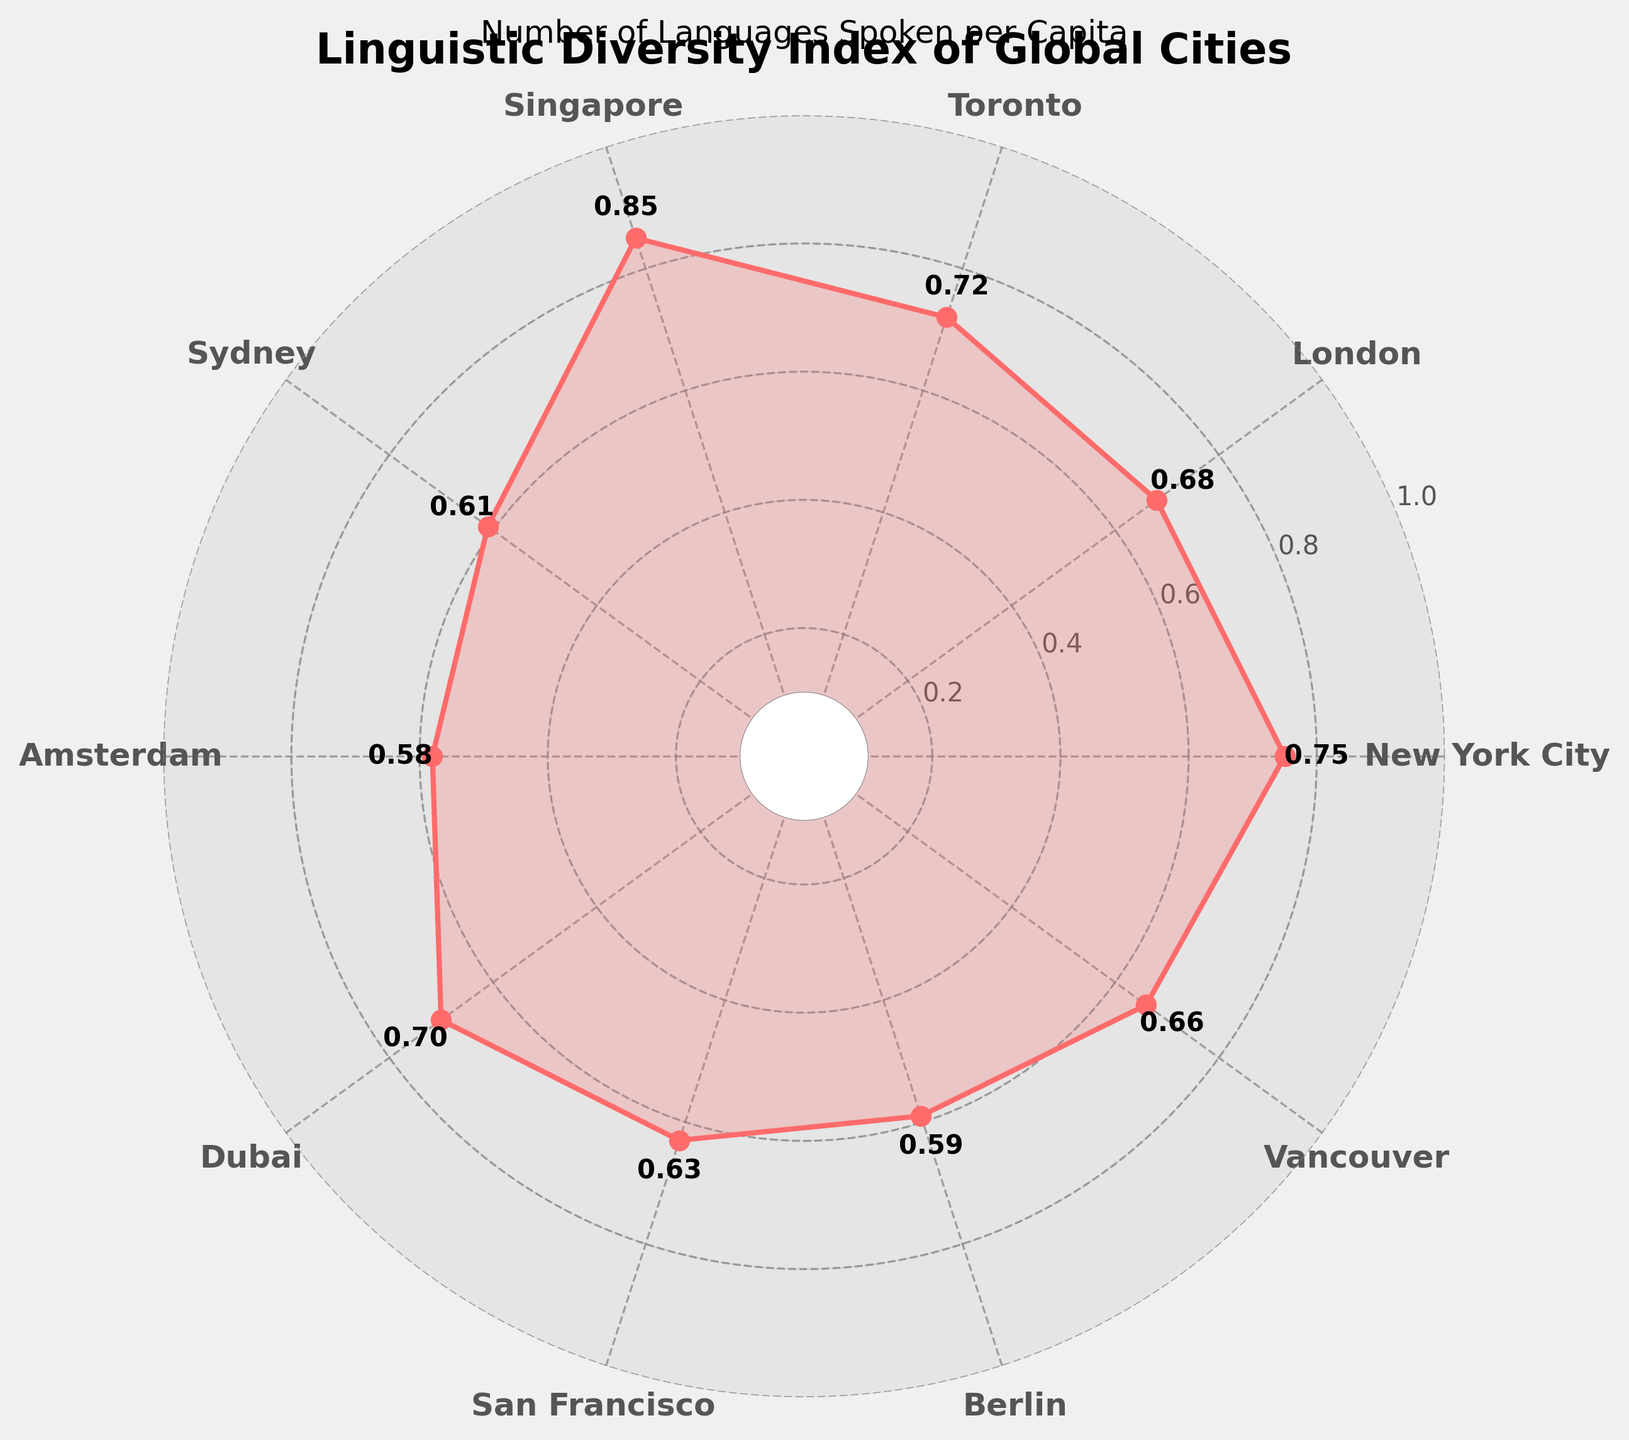What is the highest Linguistic Diversity Index value among the cities? Identify the point with the highest value on the gauge chart, which represents the highest Linguistic Diversity Index.
Answer: 0.85 (Singapore) Which city has the lowest Linguistic Diversity Index? Look for the point with the lowest value on the gauge chart and identify the corresponding city.
Answer: Amsterdam What is the Linguistic Diversity Index of New York City? Locate New York City on the gauge chart and note the value associated with it.
Answer: 0.75 How many cities have a Linguistic Diversity Index greater than 0.70? Count the number of cities on the gauge chart whose values are greater than 0.70.
Answer: 4 Which city has a higher Linguistic Diversity Index, London or Dubai? Compare the values associated with London and Dubai on the gauge chart to determine which is higher.
Answer: Dubai What is the average Linguistic Diversity Index of all cities shown? Sum the Linguistic Diversity Index values of all the cities and divide by the number of cities (10).
Answer: 0.677 Is the Linguistic Diversity Index of San Francisco above or below the average value? Calculate the average Linguistic Diversity Index value and compare it with San Francisco's value (0.63).
Answer: Below Which city has a lower Linguistic Diversity Index than Sydney but higher than Berlin? Compare the values for Sydney (0.61) and Berlin (0.59) and identify the city that fits the criteria.
Answer: San Francisco What is the average Linguistic Diversity Index for the cities with indices above 0.60? Identify cities with indices above 0.60, sum their values, and divide by the count of these cities.
Answer: 0.706 Which city has the second-lowest Linguistic Diversity Index? Identify and compare the second-lowest value on the gauge chart.
Answer: Berlin 